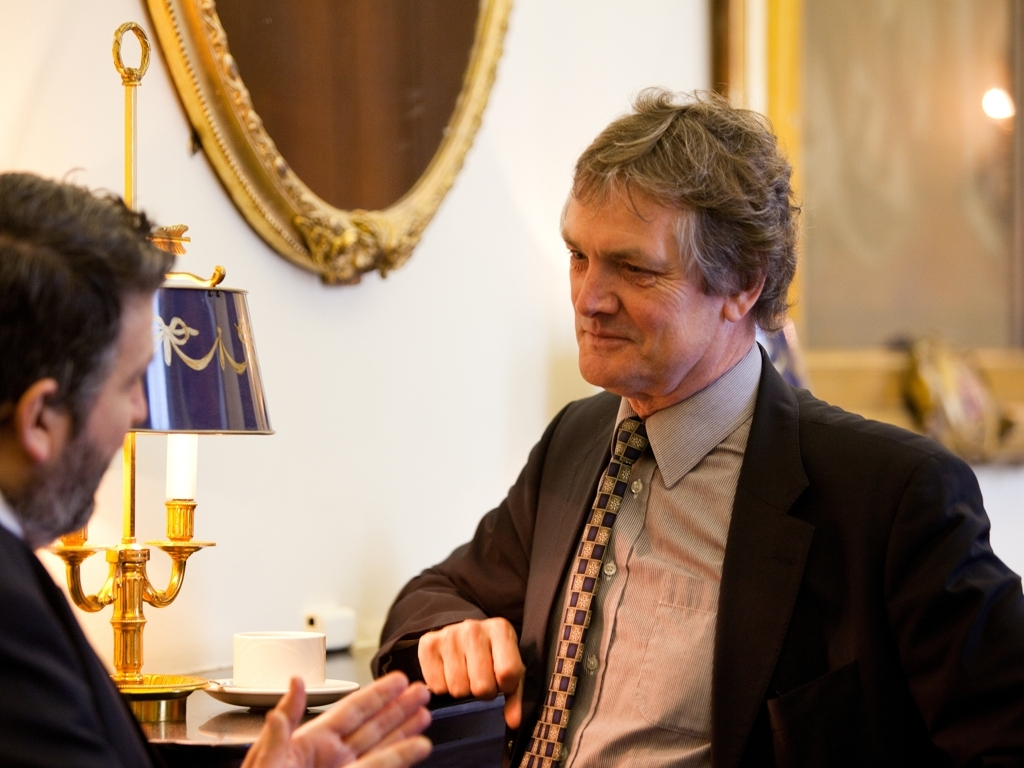What are the colors like in the image?
A. Pale
B. Dull
C. Rich
Answer with the option's letter from the given choices directly.
 C. 